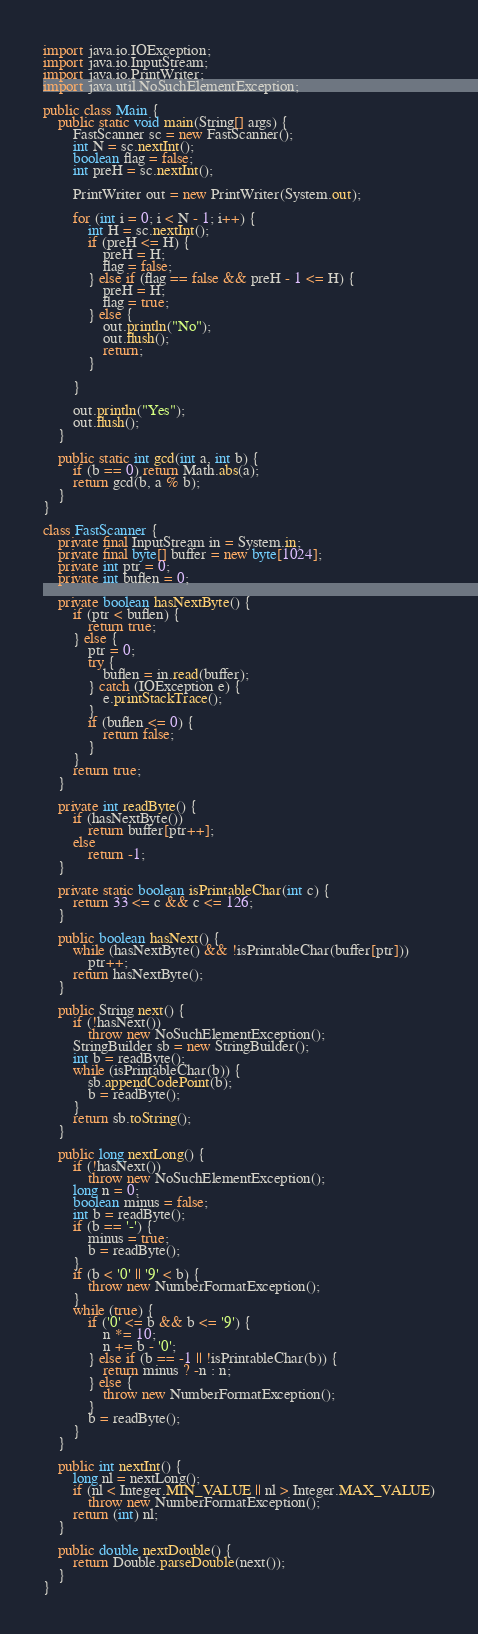Convert code to text. <code><loc_0><loc_0><loc_500><loc_500><_Java_>import java.io.IOException;
import java.io.InputStream;
import java.io.PrintWriter;
import java.util.NoSuchElementException;

public class Main {
	public static void main(String[] args) {
		FastScanner sc = new FastScanner();
		int N = sc.nextInt();
		boolean flag = false;
		int preH = sc.nextInt();

		PrintWriter out = new PrintWriter(System.out);

		for (int i = 0; i < N - 1; i++) {
			int H = sc.nextInt();
			if (preH <= H) {
				preH = H;
				flag = false;
			} else if (flag == false && preH - 1 <= H) {
				preH = H;
				flag = true;
			} else {
				out.println("No");
				out.flush();
				return;
			}

		}

		out.println("Yes");
		out.flush();
	}

	public static int gcd(int a, int b) {
	    if (b == 0) return Math.abs(a);
	    return gcd(b, a % b);
	}
}

class FastScanner {
	private final InputStream in = System.in;
	private final byte[] buffer = new byte[1024];
	private int ptr = 0;
	private int buflen = 0;

	private boolean hasNextByte() {
		if (ptr < buflen) {
			return true;
		} else {
			ptr = 0;
			try {
				buflen = in.read(buffer);
			} catch (IOException e) {
				e.printStackTrace();
			}
			if (buflen <= 0) {
				return false;
			}
		}
		return true;
	}

	private int readByte() {
		if (hasNextByte())
			return buffer[ptr++];
		else
			return -1;
	}

	private static boolean isPrintableChar(int c) {
		return 33 <= c && c <= 126;
	}

	public boolean hasNext() {
		while (hasNextByte() && !isPrintableChar(buffer[ptr]))
			ptr++;
		return hasNextByte();
	}

	public String next() {
		if (!hasNext())
			throw new NoSuchElementException();
		StringBuilder sb = new StringBuilder();
		int b = readByte();
		while (isPrintableChar(b)) {
			sb.appendCodePoint(b);
			b = readByte();
		}
		return sb.toString();
	}

	public long nextLong() {
		if (!hasNext())
			throw new NoSuchElementException();
		long n = 0;
		boolean minus = false;
		int b = readByte();
		if (b == '-') {
			minus = true;
			b = readByte();
		}
		if (b < '0' || '9' < b) {
			throw new NumberFormatException();
		}
		while (true) {
			if ('0' <= b && b <= '9') {
				n *= 10;
				n += b - '0';
			} else if (b == -1 || !isPrintableChar(b)) {
				return minus ? -n : n;
			} else {
				throw new NumberFormatException();
			}
			b = readByte();
		}
	}

	public int nextInt() {
		long nl = nextLong();
		if (nl < Integer.MIN_VALUE || nl > Integer.MAX_VALUE)
			throw new NumberFormatException();
		return (int) nl;
	}

	public double nextDouble() {
		return Double.parseDouble(next());
	}
}
</code> 